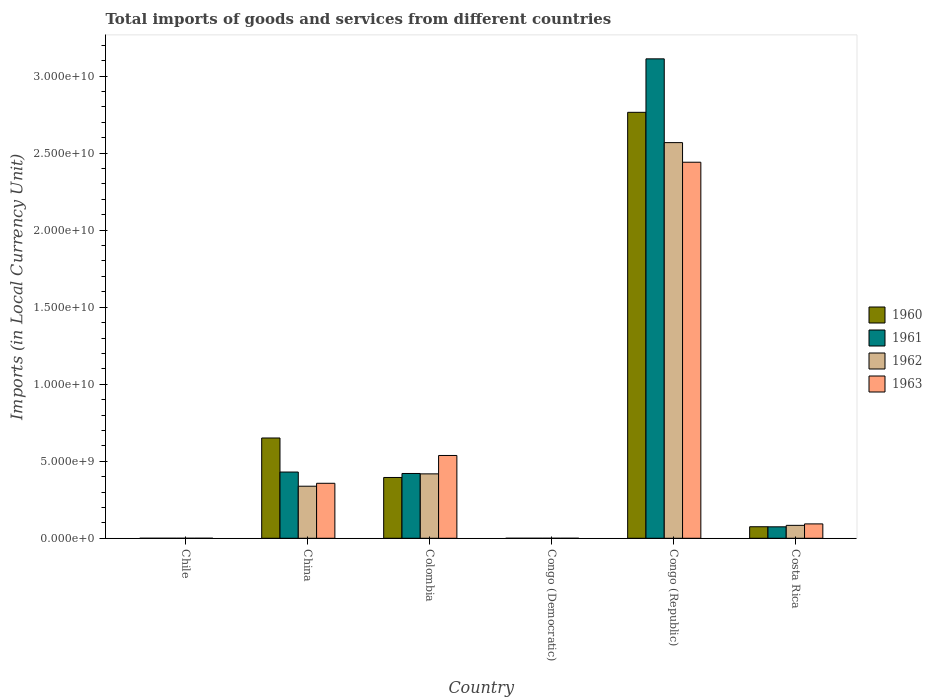How many different coloured bars are there?
Your answer should be very brief. 4. Are the number of bars per tick equal to the number of legend labels?
Your answer should be compact. Yes. How many bars are there on the 3rd tick from the left?
Offer a terse response. 4. How many bars are there on the 2nd tick from the right?
Your response must be concise. 4. What is the label of the 4th group of bars from the left?
Keep it short and to the point. Congo (Democratic). What is the Amount of goods and services imports in 1961 in Colombia?
Your answer should be very brief. 4.21e+09. Across all countries, what is the maximum Amount of goods and services imports in 1962?
Provide a short and direct response. 2.57e+1. Across all countries, what is the minimum Amount of goods and services imports in 1960?
Ensure brevity in your answer.  0. In which country was the Amount of goods and services imports in 1962 maximum?
Ensure brevity in your answer.  Congo (Republic). In which country was the Amount of goods and services imports in 1960 minimum?
Provide a succinct answer. Congo (Democratic). What is the total Amount of goods and services imports in 1962 in the graph?
Your response must be concise. 3.41e+1. What is the difference between the Amount of goods and services imports in 1960 in Colombia and that in Congo (Democratic)?
Provide a succinct answer. 3.95e+09. What is the difference between the Amount of goods and services imports in 1962 in China and the Amount of goods and services imports in 1961 in Congo (Democratic)?
Keep it short and to the point. 3.38e+09. What is the average Amount of goods and services imports in 1960 per country?
Your response must be concise. 6.48e+09. What is the difference between the Amount of goods and services imports of/in 1961 and Amount of goods and services imports of/in 1960 in Colombia?
Keep it short and to the point. 2.60e+08. What is the ratio of the Amount of goods and services imports in 1961 in Colombia to that in Congo (Republic)?
Offer a terse response. 0.14. What is the difference between the highest and the second highest Amount of goods and services imports in 1963?
Offer a very short reply. 1.90e+1. What is the difference between the highest and the lowest Amount of goods and services imports in 1963?
Ensure brevity in your answer.  2.44e+1. Is it the case that in every country, the sum of the Amount of goods and services imports in 1960 and Amount of goods and services imports in 1961 is greater than the sum of Amount of goods and services imports in 1962 and Amount of goods and services imports in 1963?
Ensure brevity in your answer.  No. What does the 4th bar from the left in China represents?
Keep it short and to the point. 1963. What does the 3rd bar from the right in Costa Rica represents?
Your answer should be very brief. 1961. Are all the bars in the graph horizontal?
Offer a terse response. No. What is the difference between two consecutive major ticks on the Y-axis?
Offer a terse response. 5.00e+09. Where does the legend appear in the graph?
Offer a very short reply. Center right. What is the title of the graph?
Ensure brevity in your answer.  Total imports of goods and services from different countries. Does "1970" appear as one of the legend labels in the graph?
Your response must be concise. No. What is the label or title of the X-axis?
Provide a succinct answer. Country. What is the label or title of the Y-axis?
Your answer should be compact. Imports (in Local Currency Unit). What is the Imports (in Local Currency Unit) in 1961 in Chile?
Your response must be concise. 8.00e+05. What is the Imports (in Local Currency Unit) of 1963 in Chile?
Offer a terse response. 1.30e+06. What is the Imports (in Local Currency Unit) in 1960 in China?
Offer a very short reply. 6.51e+09. What is the Imports (in Local Currency Unit) of 1961 in China?
Your response must be concise. 4.30e+09. What is the Imports (in Local Currency Unit) of 1962 in China?
Give a very brief answer. 3.38e+09. What is the Imports (in Local Currency Unit) of 1963 in China?
Keep it short and to the point. 3.57e+09. What is the Imports (in Local Currency Unit) of 1960 in Colombia?
Your answer should be very brief. 3.95e+09. What is the Imports (in Local Currency Unit) of 1961 in Colombia?
Provide a short and direct response. 4.21e+09. What is the Imports (in Local Currency Unit) in 1962 in Colombia?
Your answer should be very brief. 4.18e+09. What is the Imports (in Local Currency Unit) in 1963 in Colombia?
Keep it short and to the point. 5.38e+09. What is the Imports (in Local Currency Unit) of 1960 in Congo (Democratic)?
Offer a terse response. 0. What is the Imports (in Local Currency Unit) of 1961 in Congo (Democratic)?
Your response must be concise. 5.07076656504069e-5. What is the Imports (in Local Currency Unit) in 1962 in Congo (Democratic)?
Give a very brief answer. 5.906629303353841e-5. What is the Imports (in Local Currency Unit) of 1963 in Congo (Democratic)?
Keep it short and to the point. 0. What is the Imports (in Local Currency Unit) of 1960 in Congo (Republic)?
Offer a terse response. 2.77e+1. What is the Imports (in Local Currency Unit) in 1961 in Congo (Republic)?
Your answer should be very brief. 3.11e+1. What is the Imports (in Local Currency Unit) of 1962 in Congo (Republic)?
Give a very brief answer. 2.57e+1. What is the Imports (in Local Currency Unit) of 1963 in Congo (Republic)?
Keep it short and to the point. 2.44e+1. What is the Imports (in Local Currency Unit) in 1960 in Costa Rica?
Your response must be concise. 7.49e+08. What is the Imports (in Local Currency Unit) of 1961 in Costa Rica?
Your answer should be very brief. 7.44e+08. What is the Imports (in Local Currency Unit) in 1962 in Costa Rica?
Your answer should be compact. 8.40e+08. What is the Imports (in Local Currency Unit) in 1963 in Costa Rica?
Ensure brevity in your answer.  9.34e+08. Across all countries, what is the maximum Imports (in Local Currency Unit) of 1960?
Offer a terse response. 2.77e+1. Across all countries, what is the maximum Imports (in Local Currency Unit) in 1961?
Offer a terse response. 3.11e+1. Across all countries, what is the maximum Imports (in Local Currency Unit) in 1962?
Offer a very short reply. 2.57e+1. Across all countries, what is the maximum Imports (in Local Currency Unit) of 1963?
Provide a short and direct response. 2.44e+1. Across all countries, what is the minimum Imports (in Local Currency Unit) of 1960?
Your response must be concise. 0. Across all countries, what is the minimum Imports (in Local Currency Unit) of 1961?
Offer a terse response. 5.07076656504069e-5. Across all countries, what is the minimum Imports (in Local Currency Unit) in 1962?
Your answer should be compact. 5.906629303353841e-5. Across all countries, what is the minimum Imports (in Local Currency Unit) of 1963?
Offer a very short reply. 0. What is the total Imports (in Local Currency Unit) of 1960 in the graph?
Ensure brevity in your answer.  3.89e+1. What is the total Imports (in Local Currency Unit) in 1961 in the graph?
Ensure brevity in your answer.  4.04e+1. What is the total Imports (in Local Currency Unit) in 1962 in the graph?
Your answer should be very brief. 3.41e+1. What is the total Imports (in Local Currency Unit) in 1963 in the graph?
Your response must be concise. 3.43e+1. What is the difference between the Imports (in Local Currency Unit) of 1960 in Chile and that in China?
Offer a very short reply. -6.51e+09. What is the difference between the Imports (in Local Currency Unit) of 1961 in Chile and that in China?
Provide a succinct answer. -4.30e+09. What is the difference between the Imports (in Local Currency Unit) of 1962 in Chile and that in China?
Give a very brief answer. -3.38e+09. What is the difference between the Imports (in Local Currency Unit) of 1963 in Chile and that in China?
Keep it short and to the point. -3.57e+09. What is the difference between the Imports (in Local Currency Unit) in 1960 in Chile and that in Colombia?
Provide a short and direct response. -3.95e+09. What is the difference between the Imports (in Local Currency Unit) of 1961 in Chile and that in Colombia?
Your response must be concise. -4.21e+09. What is the difference between the Imports (in Local Currency Unit) of 1962 in Chile and that in Colombia?
Provide a short and direct response. -4.18e+09. What is the difference between the Imports (in Local Currency Unit) in 1963 in Chile and that in Colombia?
Offer a terse response. -5.37e+09. What is the difference between the Imports (in Local Currency Unit) in 1960 in Chile and that in Congo (Democratic)?
Give a very brief answer. 7.00e+05. What is the difference between the Imports (in Local Currency Unit) in 1961 in Chile and that in Congo (Democratic)?
Your answer should be compact. 8.00e+05. What is the difference between the Imports (in Local Currency Unit) in 1962 in Chile and that in Congo (Democratic)?
Provide a short and direct response. 8.00e+05. What is the difference between the Imports (in Local Currency Unit) of 1963 in Chile and that in Congo (Democratic)?
Make the answer very short. 1.30e+06. What is the difference between the Imports (in Local Currency Unit) in 1960 in Chile and that in Congo (Republic)?
Make the answer very short. -2.77e+1. What is the difference between the Imports (in Local Currency Unit) in 1961 in Chile and that in Congo (Republic)?
Keep it short and to the point. -3.11e+1. What is the difference between the Imports (in Local Currency Unit) of 1962 in Chile and that in Congo (Republic)?
Provide a succinct answer. -2.57e+1. What is the difference between the Imports (in Local Currency Unit) of 1963 in Chile and that in Congo (Republic)?
Ensure brevity in your answer.  -2.44e+1. What is the difference between the Imports (in Local Currency Unit) in 1960 in Chile and that in Costa Rica?
Your answer should be very brief. -7.48e+08. What is the difference between the Imports (in Local Currency Unit) of 1961 in Chile and that in Costa Rica?
Keep it short and to the point. -7.43e+08. What is the difference between the Imports (in Local Currency Unit) of 1962 in Chile and that in Costa Rica?
Offer a very short reply. -8.39e+08. What is the difference between the Imports (in Local Currency Unit) in 1963 in Chile and that in Costa Rica?
Ensure brevity in your answer.  -9.33e+08. What is the difference between the Imports (in Local Currency Unit) in 1960 in China and that in Colombia?
Provide a short and direct response. 2.56e+09. What is the difference between the Imports (in Local Currency Unit) of 1961 in China and that in Colombia?
Keep it short and to the point. 9.28e+07. What is the difference between the Imports (in Local Currency Unit) in 1962 in China and that in Colombia?
Ensure brevity in your answer.  -8.02e+08. What is the difference between the Imports (in Local Currency Unit) of 1963 in China and that in Colombia?
Your answer should be very brief. -1.81e+09. What is the difference between the Imports (in Local Currency Unit) in 1960 in China and that in Congo (Democratic)?
Make the answer very short. 6.51e+09. What is the difference between the Imports (in Local Currency Unit) in 1961 in China and that in Congo (Democratic)?
Provide a succinct answer. 4.30e+09. What is the difference between the Imports (in Local Currency Unit) of 1962 in China and that in Congo (Democratic)?
Offer a terse response. 3.38e+09. What is the difference between the Imports (in Local Currency Unit) of 1963 in China and that in Congo (Democratic)?
Provide a short and direct response. 3.57e+09. What is the difference between the Imports (in Local Currency Unit) of 1960 in China and that in Congo (Republic)?
Offer a terse response. -2.11e+1. What is the difference between the Imports (in Local Currency Unit) in 1961 in China and that in Congo (Republic)?
Your answer should be very brief. -2.68e+1. What is the difference between the Imports (in Local Currency Unit) of 1962 in China and that in Congo (Republic)?
Keep it short and to the point. -2.23e+1. What is the difference between the Imports (in Local Currency Unit) in 1963 in China and that in Congo (Republic)?
Give a very brief answer. -2.08e+1. What is the difference between the Imports (in Local Currency Unit) in 1960 in China and that in Costa Rica?
Provide a short and direct response. 5.76e+09. What is the difference between the Imports (in Local Currency Unit) in 1961 in China and that in Costa Rica?
Keep it short and to the point. 3.56e+09. What is the difference between the Imports (in Local Currency Unit) of 1962 in China and that in Costa Rica?
Your answer should be compact. 2.54e+09. What is the difference between the Imports (in Local Currency Unit) of 1963 in China and that in Costa Rica?
Make the answer very short. 2.64e+09. What is the difference between the Imports (in Local Currency Unit) in 1960 in Colombia and that in Congo (Democratic)?
Offer a very short reply. 3.95e+09. What is the difference between the Imports (in Local Currency Unit) of 1961 in Colombia and that in Congo (Democratic)?
Your answer should be very brief. 4.21e+09. What is the difference between the Imports (in Local Currency Unit) of 1962 in Colombia and that in Congo (Democratic)?
Your answer should be compact. 4.18e+09. What is the difference between the Imports (in Local Currency Unit) in 1963 in Colombia and that in Congo (Democratic)?
Your answer should be very brief. 5.38e+09. What is the difference between the Imports (in Local Currency Unit) of 1960 in Colombia and that in Congo (Republic)?
Offer a very short reply. -2.37e+1. What is the difference between the Imports (in Local Currency Unit) in 1961 in Colombia and that in Congo (Republic)?
Give a very brief answer. -2.69e+1. What is the difference between the Imports (in Local Currency Unit) of 1962 in Colombia and that in Congo (Republic)?
Offer a terse response. -2.15e+1. What is the difference between the Imports (in Local Currency Unit) of 1963 in Colombia and that in Congo (Republic)?
Give a very brief answer. -1.90e+1. What is the difference between the Imports (in Local Currency Unit) of 1960 in Colombia and that in Costa Rica?
Offer a very short reply. 3.20e+09. What is the difference between the Imports (in Local Currency Unit) of 1961 in Colombia and that in Costa Rica?
Your answer should be very brief. 3.46e+09. What is the difference between the Imports (in Local Currency Unit) of 1962 in Colombia and that in Costa Rica?
Make the answer very short. 3.34e+09. What is the difference between the Imports (in Local Currency Unit) in 1963 in Colombia and that in Costa Rica?
Provide a short and direct response. 4.44e+09. What is the difference between the Imports (in Local Currency Unit) of 1960 in Congo (Democratic) and that in Congo (Republic)?
Make the answer very short. -2.77e+1. What is the difference between the Imports (in Local Currency Unit) of 1961 in Congo (Democratic) and that in Congo (Republic)?
Offer a terse response. -3.11e+1. What is the difference between the Imports (in Local Currency Unit) in 1962 in Congo (Democratic) and that in Congo (Republic)?
Your response must be concise. -2.57e+1. What is the difference between the Imports (in Local Currency Unit) in 1963 in Congo (Democratic) and that in Congo (Republic)?
Make the answer very short. -2.44e+1. What is the difference between the Imports (in Local Currency Unit) in 1960 in Congo (Democratic) and that in Costa Rica?
Give a very brief answer. -7.49e+08. What is the difference between the Imports (in Local Currency Unit) in 1961 in Congo (Democratic) and that in Costa Rica?
Provide a succinct answer. -7.44e+08. What is the difference between the Imports (in Local Currency Unit) in 1962 in Congo (Democratic) and that in Costa Rica?
Your answer should be very brief. -8.40e+08. What is the difference between the Imports (in Local Currency Unit) in 1963 in Congo (Democratic) and that in Costa Rica?
Keep it short and to the point. -9.34e+08. What is the difference between the Imports (in Local Currency Unit) of 1960 in Congo (Republic) and that in Costa Rica?
Offer a terse response. 2.69e+1. What is the difference between the Imports (in Local Currency Unit) of 1961 in Congo (Republic) and that in Costa Rica?
Offer a very short reply. 3.04e+1. What is the difference between the Imports (in Local Currency Unit) in 1962 in Congo (Republic) and that in Costa Rica?
Provide a short and direct response. 2.48e+1. What is the difference between the Imports (in Local Currency Unit) of 1963 in Congo (Republic) and that in Costa Rica?
Offer a terse response. 2.35e+1. What is the difference between the Imports (in Local Currency Unit) in 1960 in Chile and the Imports (in Local Currency Unit) in 1961 in China?
Offer a very short reply. -4.30e+09. What is the difference between the Imports (in Local Currency Unit) of 1960 in Chile and the Imports (in Local Currency Unit) of 1962 in China?
Offer a very short reply. -3.38e+09. What is the difference between the Imports (in Local Currency Unit) of 1960 in Chile and the Imports (in Local Currency Unit) of 1963 in China?
Your response must be concise. -3.57e+09. What is the difference between the Imports (in Local Currency Unit) in 1961 in Chile and the Imports (in Local Currency Unit) in 1962 in China?
Ensure brevity in your answer.  -3.38e+09. What is the difference between the Imports (in Local Currency Unit) of 1961 in Chile and the Imports (in Local Currency Unit) of 1963 in China?
Provide a short and direct response. -3.57e+09. What is the difference between the Imports (in Local Currency Unit) of 1962 in Chile and the Imports (in Local Currency Unit) of 1963 in China?
Provide a short and direct response. -3.57e+09. What is the difference between the Imports (in Local Currency Unit) in 1960 in Chile and the Imports (in Local Currency Unit) in 1961 in Colombia?
Your response must be concise. -4.21e+09. What is the difference between the Imports (in Local Currency Unit) in 1960 in Chile and the Imports (in Local Currency Unit) in 1962 in Colombia?
Make the answer very short. -4.18e+09. What is the difference between the Imports (in Local Currency Unit) of 1960 in Chile and the Imports (in Local Currency Unit) of 1963 in Colombia?
Make the answer very short. -5.37e+09. What is the difference between the Imports (in Local Currency Unit) in 1961 in Chile and the Imports (in Local Currency Unit) in 1962 in Colombia?
Keep it short and to the point. -4.18e+09. What is the difference between the Imports (in Local Currency Unit) in 1961 in Chile and the Imports (in Local Currency Unit) in 1963 in Colombia?
Your answer should be compact. -5.37e+09. What is the difference between the Imports (in Local Currency Unit) of 1962 in Chile and the Imports (in Local Currency Unit) of 1963 in Colombia?
Make the answer very short. -5.37e+09. What is the difference between the Imports (in Local Currency Unit) in 1960 in Chile and the Imports (in Local Currency Unit) in 1961 in Congo (Democratic)?
Your answer should be compact. 7.00e+05. What is the difference between the Imports (in Local Currency Unit) of 1960 in Chile and the Imports (in Local Currency Unit) of 1962 in Congo (Democratic)?
Your answer should be very brief. 7.00e+05. What is the difference between the Imports (in Local Currency Unit) of 1960 in Chile and the Imports (in Local Currency Unit) of 1963 in Congo (Democratic)?
Provide a short and direct response. 7.00e+05. What is the difference between the Imports (in Local Currency Unit) in 1961 in Chile and the Imports (in Local Currency Unit) in 1962 in Congo (Democratic)?
Offer a terse response. 8.00e+05. What is the difference between the Imports (in Local Currency Unit) in 1961 in Chile and the Imports (in Local Currency Unit) in 1963 in Congo (Democratic)?
Offer a very short reply. 8.00e+05. What is the difference between the Imports (in Local Currency Unit) in 1962 in Chile and the Imports (in Local Currency Unit) in 1963 in Congo (Democratic)?
Your answer should be very brief. 8.00e+05. What is the difference between the Imports (in Local Currency Unit) in 1960 in Chile and the Imports (in Local Currency Unit) in 1961 in Congo (Republic)?
Provide a succinct answer. -3.11e+1. What is the difference between the Imports (in Local Currency Unit) in 1960 in Chile and the Imports (in Local Currency Unit) in 1962 in Congo (Republic)?
Offer a terse response. -2.57e+1. What is the difference between the Imports (in Local Currency Unit) of 1960 in Chile and the Imports (in Local Currency Unit) of 1963 in Congo (Republic)?
Make the answer very short. -2.44e+1. What is the difference between the Imports (in Local Currency Unit) of 1961 in Chile and the Imports (in Local Currency Unit) of 1962 in Congo (Republic)?
Ensure brevity in your answer.  -2.57e+1. What is the difference between the Imports (in Local Currency Unit) in 1961 in Chile and the Imports (in Local Currency Unit) in 1963 in Congo (Republic)?
Keep it short and to the point. -2.44e+1. What is the difference between the Imports (in Local Currency Unit) of 1962 in Chile and the Imports (in Local Currency Unit) of 1963 in Congo (Republic)?
Keep it short and to the point. -2.44e+1. What is the difference between the Imports (in Local Currency Unit) in 1960 in Chile and the Imports (in Local Currency Unit) in 1961 in Costa Rica?
Provide a succinct answer. -7.43e+08. What is the difference between the Imports (in Local Currency Unit) in 1960 in Chile and the Imports (in Local Currency Unit) in 1962 in Costa Rica?
Provide a short and direct response. -8.39e+08. What is the difference between the Imports (in Local Currency Unit) in 1960 in Chile and the Imports (in Local Currency Unit) in 1963 in Costa Rica?
Ensure brevity in your answer.  -9.33e+08. What is the difference between the Imports (in Local Currency Unit) of 1961 in Chile and the Imports (in Local Currency Unit) of 1962 in Costa Rica?
Ensure brevity in your answer.  -8.39e+08. What is the difference between the Imports (in Local Currency Unit) in 1961 in Chile and the Imports (in Local Currency Unit) in 1963 in Costa Rica?
Keep it short and to the point. -9.33e+08. What is the difference between the Imports (in Local Currency Unit) of 1962 in Chile and the Imports (in Local Currency Unit) of 1963 in Costa Rica?
Your answer should be very brief. -9.33e+08. What is the difference between the Imports (in Local Currency Unit) of 1960 in China and the Imports (in Local Currency Unit) of 1961 in Colombia?
Ensure brevity in your answer.  2.30e+09. What is the difference between the Imports (in Local Currency Unit) in 1960 in China and the Imports (in Local Currency Unit) in 1962 in Colombia?
Offer a terse response. 2.33e+09. What is the difference between the Imports (in Local Currency Unit) in 1960 in China and the Imports (in Local Currency Unit) in 1963 in Colombia?
Provide a succinct answer. 1.13e+09. What is the difference between the Imports (in Local Currency Unit) of 1961 in China and the Imports (in Local Currency Unit) of 1962 in Colombia?
Keep it short and to the point. 1.18e+08. What is the difference between the Imports (in Local Currency Unit) of 1961 in China and the Imports (in Local Currency Unit) of 1963 in Colombia?
Give a very brief answer. -1.08e+09. What is the difference between the Imports (in Local Currency Unit) of 1962 in China and the Imports (in Local Currency Unit) of 1963 in Colombia?
Provide a short and direct response. -2.00e+09. What is the difference between the Imports (in Local Currency Unit) in 1960 in China and the Imports (in Local Currency Unit) in 1961 in Congo (Democratic)?
Give a very brief answer. 6.51e+09. What is the difference between the Imports (in Local Currency Unit) in 1960 in China and the Imports (in Local Currency Unit) in 1962 in Congo (Democratic)?
Your answer should be very brief. 6.51e+09. What is the difference between the Imports (in Local Currency Unit) in 1960 in China and the Imports (in Local Currency Unit) in 1963 in Congo (Democratic)?
Provide a succinct answer. 6.51e+09. What is the difference between the Imports (in Local Currency Unit) of 1961 in China and the Imports (in Local Currency Unit) of 1962 in Congo (Democratic)?
Offer a very short reply. 4.30e+09. What is the difference between the Imports (in Local Currency Unit) of 1961 in China and the Imports (in Local Currency Unit) of 1963 in Congo (Democratic)?
Your answer should be compact. 4.30e+09. What is the difference between the Imports (in Local Currency Unit) in 1962 in China and the Imports (in Local Currency Unit) in 1963 in Congo (Democratic)?
Your answer should be compact. 3.38e+09. What is the difference between the Imports (in Local Currency Unit) in 1960 in China and the Imports (in Local Currency Unit) in 1961 in Congo (Republic)?
Provide a succinct answer. -2.46e+1. What is the difference between the Imports (in Local Currency Unit) in 1960 in China and the Imports (in Local Currency Unit) in 1962 in Congo (Republic)?
Your answer should be very brief. -1.92e+1. What is the difference between the Imports (in Local Currency Unit) in 1960 in China and the Imports (in Local Currency Unit) in 1963 in Congo (Republic)?
Make the answer very short. -1.79e+1. What is the difference between the Imports (in Local Currency Unit) in 1961 in China and the Imports (in Local Currency Unit) in 1962 in Congo (Republic)?
Keep it short and to the point. -2.14e+1. What is the difference between the Imports (in Local Currency Unit) in 1961 in China and the Imports (in Local Currency Unit) in 1963 in Congo (Republic)?
Offer a terse response. -2.01e+1. What is the difference between the Imports (in Local Currency Unit) in 1962 in China and the Imports (in Local Currency Unit) in 1963 in Congo (Republic)?
Give a very brief answer. -2.10e+1. What is the difference between the Imports (in Local Currency Unit) of 1960 in China and the Imports (in Local Currency Unit) of 1961 in Costa Rica?
Provide a short and direct response. 5.77e+09. What is the difference between the Imports (in Local Currency Unit) in 1960 in China and the Imports (in Local Currency Unit) in 1962 in Costa Rica?
Your response must be concise. 5.67e+09. What is the difference between the Imports (in Local Currency Unit) in 1960 in China and the Imports (in Local Currency Unit) in 1963 in Costa Rica?
Make the answer very short. 5.58e+09. What is the difference between the Imports (in Local Currency Unit) in 1961 in China and the Imports (in Local Currency Unit) in 1962 in Costa Rica?
Provide a short and direct response. 3.46e+09. What is the difference between the Imports (in Local Currency Unit) in 1961 in China and the Imports (in Local Currency Unit) in 1963 in Costa Rica?
Provide a succinct answer. 3.37e+09. What is the difference between the Imports (in Local Currency Unit) in 1962 in China and the Imports (in Local Currency Unit) in 1963 in Costa Rica?
Offer a very short reply. 2.45e+09. What is the difference between the Imports (in Local Currency Unit) in 1960 in Colombia and the Imports (in Local Currency Unit) in 1961 in Congo (Democratic)?
Your answer should be very brief. 3.95e+09. What is the difference between the Imports (in Local Currency Unit) of 1960 in Colombia and the Imports (in Local Currency Unit) of 1962 in Congo (Democratic)?
Offer a very short reply. 3.95e+09. What is the difference between the Imports (in Local Currency Unit) in 1960 in Colombia and the Imports (in Local Currency Unit) in 1963 in Congo (Democratic)?
Ensure brevity in your answer.  3.95e+09. What is the difference between the Imports (in Local Currency Unit) in 1961 in Colombia and the Imports (in Local Currency Unit) in 1962 in Congo (Democratic)?
Ensure brevity in your answer.  4.21e+09. What is the difference between the Imports (in Local Currency Unit) of 1961 in Colombia and the Imports (in Local Currency Unit) of 1963 in Congo (Democratic)?
Provide a succinct answer. 4.21e+09. What is the difference between the Imports (in Local Currency Unit) of 1962 in Colombia and the Imports (in Local Currency Unit) of 1963 in Congo (Democratic)?
Provide a short and direct response. 4.18e+09. What is the difference between the Imports (in Local Currency Unit) of 1960 in Colombia and the Imports (in Local Currency Unit) of 1961 in Congo (Republic)?
Provide a succinct answer. -2.72e+1. What is the difference between the Imports (in Local Currency Unit) of 1960 in Colombia and the Imports (in Local Currency Unit) of 1962 in Congo (Republic)?
Give a very brief answer. -2.17e+1. What is the difference between the Imports (in Local Currency Unit) in 1960 in Colombia and the Imports (in Local Currency Unit) in 1963 in Congo (Republic)?
Keep it short and to the point. -2.05e+1. What is the difference between the Imports (in Local Currency Unit) in 1961 in Colombia and the Imports (in Local Currency Unit) in 1962 in Congo (Republic)?
Offer a terse response. -2.15e+1. What is the difference between the Imports (in Local Currency Unit) of 1961 in Colombia and the Imports (in Local Currency Unit) of 1963 in Congo (Republic)?
Offer a very short reply. -2.02e+1. What is the difference between the Imports (in Local Currency Unit) in 1962 in Colombia and the Imports (in Local Currency Unit) in 1963 in Congo (Republic)?
Your answer should be compact. -2.02e+1. What is the difference between the Imports (in Local Currency Unit) of 1960 in Colombia and the Imports (in Local Currency Unit) of 1961 in Costa Rica?
Your response must be concise. 3.20e+09. What is the difference between the Imports (in Local Currency Unit) of 1960 in Colombia and the Imports (in Local Currency Unit) of 1962 in Costa Rica?
Offer a terse response. 3.11e+09. What is the difference between the Imports (in Local Currency Unit) in 1960 in Colombia and the Imports (in Local Currency Unit) in 1963 in Costa Rica?
Provide a succinct answer. 3.01e+09. What is the difference between the Imports (in Local Currency Unit) of 1961 in Colombia and the Imports (in Local Currency Unit) of 1962 in Costa Rica?
Offer a terse response. 3.37e+09. What is the difference between the Imports (in Local Currency Unit) of 1961 in Colombia and the Imports (in Local Currency Unit) of 1963 in Costa Rica?
Make the answer very short. 3.27e+09. What is the difference between the Imports (in Local Currency Unit) in 1962 in Colombia and the Imports (in Local Currency Unit) in 1963 in Costa Rica?
Ensure brevity in your answer.  3.25e+09. What is the difference between the Imports (in Local Currency Unit) of 1960 in Congo (Democratic) and the Imports (in Local Currency Unit) of 1961 in Congo (Republic)?
Give a very brief answer. -3.11e+1. What is the difference between the Imports (in Local Currency Unit) in 1960 in Congo (Democratic) and the Imports (in Local Currency Unit) in 1962 in Congo (Republic)?
Provide a short and direct response. -2.57e+1. What is the difference between the Imports (in Local Currency Unit) of 1960 in Congo (Democratic) and the Imports (in Local Currency Unit) of 1963 in Congo (Republic)?
Provide a succinct answer. -2.44e+1. What is the difference between the Imports (in Local Currency Unit) in 1961 in Congo (Democratic) and the Imports (in Local Currency Unit) in 1962 in Congo (Republic)?
Ensure brevity in your answer.  -2.57e+1. What is the difference between the Imports (in Local Currency Unit) in 1961 in Congo (Democratic) and the Imports (in Local Currency Unit) in 1963 in Congo (Republic)?
Provide a succinct answer. -2.44e+1. What is the difference between the Imports (in Local Currency Unit) of 1962 in Congo (Democratic) and the Imports (in Local Currency Unit) of 1963 in Congo (Republic)?
Provide a short and direct response. -2.44e+1. What is the difference between the Imports (in Local Currency Unit) of 1960 in Congo (Democratic) and the Imports (in Local Currency Unit) of 1961 in Costa Rica?
Give a very brief answer. -7.44e+08. What is the difference between the Imports (in Local Currency Unit) of 1960 in Congo (Democratic) and the Imports (in Local Currency Unit) of 1962 in Costa Rica?
Provide a succinct answer. -8.40e+08. What is the difference between the Imports (in Local Currency Unit) of 1960 in Congo (Democratic) and the Imports (in Local Currency Unit) of 1963 in Costa Rica?
Ensure brevity in your answer.  -9.34e+08. What is the difference between the Imports (in Local Currency Unit) of 1961 in Congo (Democratic) and the Imports (in Local Currency Unit) of 1962 in Costa Rica?
Provide a succinct answer. -8.40e+08. What is the difference between the Imports (in Local Currency Unit) of 1961 in Congo (Democratic) and the Imports (in Local Currency Unit) of 1963 in Costa Rica?
Your answer should be compact. -9.34e+08. What is the difference between the Imports (in Local Currency Unit) of 1962 in Congo (Democratic) and the Imports (in Local Currency Unit) of 1963 in Costa Rica?
Make the answer very short. -9.34e+08. What is the difference between the Imports (in Local Currency Unit) in 1960 in Congo (Republic) and the Imports (in Local Currency Unit) in 1961 in Costa Rica?
Your response must be concise. 2.69e+1. What is the difference between the Imports (in Local Currency Unit) of 1960 in Congo (Republic) and the Imports (in Local Currency Unit) of 1962 in Costa Rica?
Provide a short and direct response. 2.68e+1. What is the difference between the Imports (in Local Currency Unit) of 1960 in Congo (Republic) and the Imports (in Local Currency Unit) of 1963 in Costa Rica?
Make the answer very short. 2.67e+1. What is the difference between the Imports (in Local Currency Unit) of 1961 in Congo (Republic) and the Imports (in Local Currency Unit) of 1962 in Costa Rica?
Offer a terse response. 3.03e+1. What is the difference between the Imports (in Local Currency Unit) in 1961 in Congo (Republic) and the Imports (in Local Currency Unit) in 1963 in Costa Rica?
Provide a short and direct response. 3.02e+1. What is the difference between the Imports (in Local Currency Unit) in 1962 in Congo (Republic) and the Imports (in Local Currency Unit) in 1963 in Costa Rica?
Provide a succinct answer. 2.48e+1. What is the average Imports (in Local Currency Unit) in 1960 per country?
Make the answer very short. 6.48e+09. What is the average Imports (in Local Currency Unit) in 1961 per country?
Your response must be concise. 6.73e+09. What is the average Imports (in Local Currency Unit) of 1962 per country?
Your answer should be compact. 5.68e+09. What is the average Imports (in Local Currency Unit) in 1963 per country?
Give a very brief answer. 5.72e+09. What is the difference between the Imports (in Local Currency Unit) of 1960 and Imports (in Local Currency Unit) of 1963 in Chile?
Provide a short and direct response. -6.00e+05. What is the difference between the Imports (in Local Currency Unit) of 1961 and Imports (in Local Currency Unit) of 1963 in Chile?
Offer a terse response. -5.00e+05. What is the difference between the Imports (in Local Currency Unit) of 1962 and Imports (in Local Currency Unit) of 1963 in Chile?
Give a very brief answer. -5.00e+05. What is the difference between the Imports (in Local Currency Unit) of 1960 and Imports (in Local Currency Unit) of 1961 in China?
Give a very brief answer. 2.21e+09. What is the difference between the Imports (in Local Currency Unit) of 1960 and Imports (in Local Currency Unit) of 1962 in China?
Provide a succinct answer. 3.13e+09. What is the difference between the Imports (in Local Currency Unit) in 1960 and Imports (in Local Currency Unit) in 1963 in China?
Keep it short and to the point. 2.94e+09. What is the difference between the Imports (in Local Currency Unit) of 1961 and Imports (in Local Currency Unit) of 1962 in China?
Keep it short and to the point. 9.20e+08. What is the difference between the Imports (in Local Currency Unit) of 1961 and Imports (in Local Currency Unit) of 1963 in China?
Provide a succinct answer. 7.30e+08. What is the difference between the Imports (in Local Currency Unit) of 1962 and Imports (in Local Currency Unit) of 1963 in China?
Your response must be concise. -1.90e+08. What is the difference between the Imports (in Local Currency Unit) in 1960 and Imports (in Local Currency Unit) in 1961 in Colombia?
Your answer should be very brief. -2.60e+08. What is the difference between the Imports (in Local Currency Unit) of 1960 and Imports (in Local Currency Unit) of 1962 in Colombia?
Provide a short and direct response. -2.35e+08. What is the difference between the Imports (in Local Currency Unit) in 1960 and Imports (in Local Currency Unit) in 1963 in Colombia?
Ensure brevity in your answer.  -1.43e+09. What is the difference between the Imports (in Local Currency Unit) of 1961 and Imports (in Local Currency Unit) of 1962 in Colombia?
Your response must be concise. 2.55e+07. What is the difference between the Imports (in Local Currency Unit) of 1961 and Imports (in Local Currency Unit) of 1963 in Colombia?
Provide a succinct answer. -1.17e+09. What is the difference between the Imports (in Local Currency Unit) of 1962 and Imports (in Local Currency Unit) of 1963 in Colombia?
Your answer should be compact. -1.19e+09. What is the difference between the Imports (in Local Currency Unit) of 1960 and Imports (in Local Currency Unit) of 1962 in Congo (Democratic)?
Your answer should be compact. 0. What is the difference between the Imports (in Local Currency Unit) of 1960 and Imports (in Local Currency Unit) of 1963 in Congo (Democratic)?
Ensure brevity in your answer.  -0. What is the difference between the Imports (in Local Currency Unit) of 1961 and Imports (in Local Currency Unit) of 1963 in Congo (Democratic)?
Provide a short and direct response. -0. What is the difference between the Imports (in Local Currency Unit) of 1962 and Imports (in Local Currency Unit) of 1963 in Congo (Democratic)?
Give a very brief answer. -0. What is the difference between the Imports (in Local Currency Unit) of 1960 and Imports (in Local Currency Unit) of 1961 in Congo (Republic)?
Offer a very short reply. -3.47e+09. What is the difference between the Imports (in Local Currency Unit) in 1960 and Imports (in Local Currency Unit) in 1962 in Congo (Republic)?
Provide a short and direct response. 1.97e+09. What is the difference between the Imports (in Local Currency Unit) in 1960 and Imports (in Local Currency Unit) in 1963 in Congo (Republic)?
Offer a very short reply. 3.24e+09. What is the difference between the Imports (in Local Currency Unit) in 1961 and Imports (in Local Currency Unit) in 1962 in Congo (Republic)?
Keep it short and to the point. 5.44e+09. What is the difference between the Imports (in Local Currency Unit) of 1961 and Imports (in Local Currency Unit) of 1963 in Congo (Republic)?
Give a very brief answer. 6.71e+09. What is the difference between the Imports (in Local Currency Unit) in 1962 and Imports (in Local Currency Unit) in 1963 in Congo (Republic)?
Your response must be concise. 1.27e+09. What is the difference between the Imports (in Local Currency Unit) of 1960 and Imports (in Local Currency Unit) of 1961 in Costa Rica?
Provide a short and direct response. 4.80e+06. What is the difference between the Imports (in Local Currency Unit) of 1960 and Imports (in Local Currency Unit) of 1962 in Costa Rica?
Offer a very short reply. -9.07e+07. What is the difference between the Imports (in Local Currency Unit) in 1960 and Imports (in Local Currency Unit) in 1963 in Costa Rica?
Offer a terse response. -1.85e+08. What is the difference between the Imports (in Local Currency Unit) in 1961 and Imports (in Local Currency Unit) in 1962 in Costa Rica?
Offer a very short reply. -9.55e+07. What is the difference between the Imports (in Local Currency Unit) of 1961 and Imports (in Local Currency Unit) of 1963 in Costa Rica?
Offer a terse response. -1.90e+08. What is the difference between the Imports (in Local Currency Unit) of 1962 and Imports (in Local Currency Unit) of 1963 in Costa Rica?
Make the answer very short. -9.44e+07. What is the ratio of the Imports (in Local Currency Unit) in 1960 in Chile to that in China?
Your response must be concise. 0. What is the ratio of the Imports (in Local Currency Unit) of 1962 in Chile to that in China?
Give a very brief answer. 0. What is the ratio of the Imports (in Local Currency Unit) of 1963 in Chile to that in China?
Make the answer very short. 0. What is the ratio of the Imports (in Local Currency Unit) of 1960 in Chile to that in Colombia?
Provide a short and direct response. 0. What is the ratio of the Imports (in Local Currency Unit) in 1962 in Chile to that in Colombia?
Offer a terse response. 0. What is the ratio of the Imports (in Local Currency Unit) of 1963 in Chile to that in Colombia?
Provide a short and direct response. 0. What is the ratio of the Imports (in Local Currency Unit) of 1960 in Chile to that in Congo (Democratic)?
Your answer should be compact. 6.31e+09. What is the ratio of the Imports (in Local Currency Unit) of 1961 in Chile to that in Congo (Democratic)?
Offer a very short reply. 1.58e+1. What is the ratio of the Imports (in Local Currency Unit) of 1962 in Chile to that in Congo (Democratic)?
Make the answer very short. 1.35e+1. What is the ratio of the Imports (in Local Currency Unit) of 1963 in Chile to that in Congo (Democratic)?
Offer a very short reply. 2.62e+09. What is the ratio of the Imports (in Local Currency Unit) of 1961 in Chile to that in Congo (Republic)?
Provide a short and direct response. 0. What is the ratio of the Imports (in Local Currency Unit) of 1960 in Chile to that in Costa Rica?
Provide a succinct answer. 0. What is the ratio of the Imports (in Local Currency Unit) in 1961 in Chile to that in Costa Rica?
Give a very brief answer. 0. What is the ratio of the Imports (in Local Currency Unit) in 1962 in Chile to that in Costa Rica?
Ensure brevity in your answer.  0. What is the ratio of the Imports (in Local Currency Unit) of 1963 in Chile to that in Costa Rica?
Make the answer very short. 0. What is the ratio of the Imports (in Local Currency Unit) in 1960 in China to that in Colombia?
Ensure brevity in your answer.  1.65. What is the ratio of the Imports (in Local Currency Unit) in 1961 in China to that in Colombia?
Your response must be concise. 1.02. What is the ratio of the Imports (in Local Currency Unit) of 1962 in China to that in Colombia?
Keep it short and to the point. 0.81. What is the ratio of the Imports (in Local Currency Unit) in 1963 in China to that in Colombia?
Keep it short and to the point. 0.66. What is the ratio of the Imports (in Local Currency Unit) of 1960 in China to that in Congo (Democratic)?
Give a very brief answer. 5.87e+13. What is the ratio of the Imports (in Local Currency Unit) of 1961 in China to that in Congo (Democratic)?
Offer a terse response. 8.48e+13. What is the ratio of the Imports (in Local Currency Unit) of 1962 in China to that in Congo (Democratic)?
Your answer should be very brief. 5.72e+13. What is the ratio of the Imports (in Local Currency Unit) of 1963 in China to that in Congo (Democratic)?
Provide a succinct answer. 7.18e+12. What is the ratio of the Imports (in Local Currency Unit) of 1960 in China to that in Congo (Republic)?
Offer a very short reply. 0.24. What is the ratio of the Imports (in Local Currency Unit) of 1961 in China to that in Congo (Republic)?
Ensure brevity in your answer.  0.14. What is the ratio of the Imports (in Local Currency Unit) in 1962 in China to that in Congo (Republic)?
Your answer should be compact. 0.13. What is the ratio of the Imports (in Local Currency Unit) of 1963 in China to that in Congo (Republic)?
Provide a short and direct response. 0.15. What is the ratio of the Imports (in Local Currency Unit) of 1960 in China to that in Costa Rica?
Make the answer very short. 8.69. What is the ratio of the Imports (in Local Currency Unit) in 1961 in China to that in Costa Rica?
Keep it short and to the point. 5.78. What is the ratio of the Imports (in Local Currency Unit) in 1962 in China to that in Costa Rica?
Provide a short and direct response. 4.03. What is the ratio of the Imports (in Local Currency Unit) of 1963 in China to that in Costa Rica?
Provide a short and direct response. 3.82. What is the ratio of the Imports (in Local Currency Unit) in 1960 in Colombia to that in Congo (Democratic)?
Provide a succinct answer. 3.56e+13. What is the ratio of the Imports (in Local Currency Unit) in 1961 in Colombia to that in Congo (Democratic)?
Ensure brevity in your answer.  8.30e+13. What is the ratio of the Imports (in Local Currency Unit) in 1962 in Colombia to that in Congo (Democratic)?
Your answer should be very brief. 7.08e+13. What is the ratio of the Imports (in Local Currency Unit) of 1963 in Colombia to that in Congo (Democratic)?
Ensure brevity in your answer.  1.08e+13. What is the ratio of the Imports (in Local Currency Unit) of 1960 in Colombia to that in Congo (Republic)?
Provide a succinct answer. 0.14. What is the ratio of the Imports (in Local Currency Unit) of 1961 in Colombia to that in Congo (Republic)?
Keep it short and to the point. 0.14. What is the ratio of the Imports (in Local Currency Unit) in 1962 in Colombia to that in Congo (Republic)?
Keep it short and to the point. 0.16. What is the ratio of the Imports (in Local Currency Unit) in 1963 in Colombia to that in Congo (Republic)?
Offer a terse response. 0.22. What is the ratio of the Imports (in Local Currency Unit) of 1960 in Colombia to that in Costa Rica?
Offer a terse response. 5.27. What is the ratio of the Imports (in Local Currency Unit) of 1961 in Colombia to that in Costa Rica?
Your answer should be compact. 5.65. What is the ratio of the Imports (in Local Currency Unit) in 1962 in Colombia to that in Costa Rica?
Your response must be concise. 4.98. What is the ratio of the Imports (in Local Currency Unit) of 1963 in Colombia to that in Costa Rica?
Ensure brevity in your answer.  5.76. What is the ratio of the Imports (in Local Currency Unit) in 1961 in Congo (Democratic) to that in Congo (Republic)?
Offer a very short reply. 0. What is the ratio of the Imports (in Local Currency Unit) of 1963 in Congo (Democratic) to that in Congo (Republic)?
Make the answer very short. 0. What is the ratio of the Imports (in Local Currency Unit) in 1963 in Congo (Democratic) to that in Costa Rica?
Provide a short and direct response. 0. What is the ratio of the Imports (in Local Currency Unit) of 1960 in Congo (Republic) to that in Costa Rica?
Ensure brevity in your answer.  36.93. What is the ratio of the Imports (in Local Currency Unit) in 1961 in Congo (Republic) to that in Costa Rica?
Keep it short and to the point. 41.83. What is the ratio of the Imports (in Local Currency Unit) of 1962 in Congo (Republic) to that in Costa Rica?
Offer a very short reply. 30.59. What is the ratio of the Imports (in Local Currency Unit) in 1963 in Congo (Republic) to that in Costa Rica?
Your response must be concise. 26.14. What is the difference between the highest and the second highest Imports (in Local Currency Unit) of 1960?
Make the answer very short. 2.11e+1. What is the difference between the highest and the second highest Imports (in Local Currency Unit) in 1961?
Ensure brevity in your answer.  2.68e+1. What is the difference between the highest and the second highest Imports (in Local Currency Unit) of 1962?
Keep it short and to the point. 2.15e+1. What is the difference between the highest and the second highest Imports (in Local Currency Unit) of 1963?
Your answer should be compact. 1.90e+1. What is the difference between the highest and the lowest Imports (in Local Currency Unit) in 1960?
Keep it short and to the point. 2.77e+1. What is the difference between the highest and the lowest Imports (in Local Currency Unit) of 1961?
Offer a very short reply. 3.11e+1. What is the difference between the highest and the lowest Imports (in Local Currency Unit) in 1962?
Offer a very short reply. 2.57e+1. What is the difference between the highest and the lowest Imports (in Local Currency Unit) of 1963?
Provide a short and direct response. 2.44e+1. 